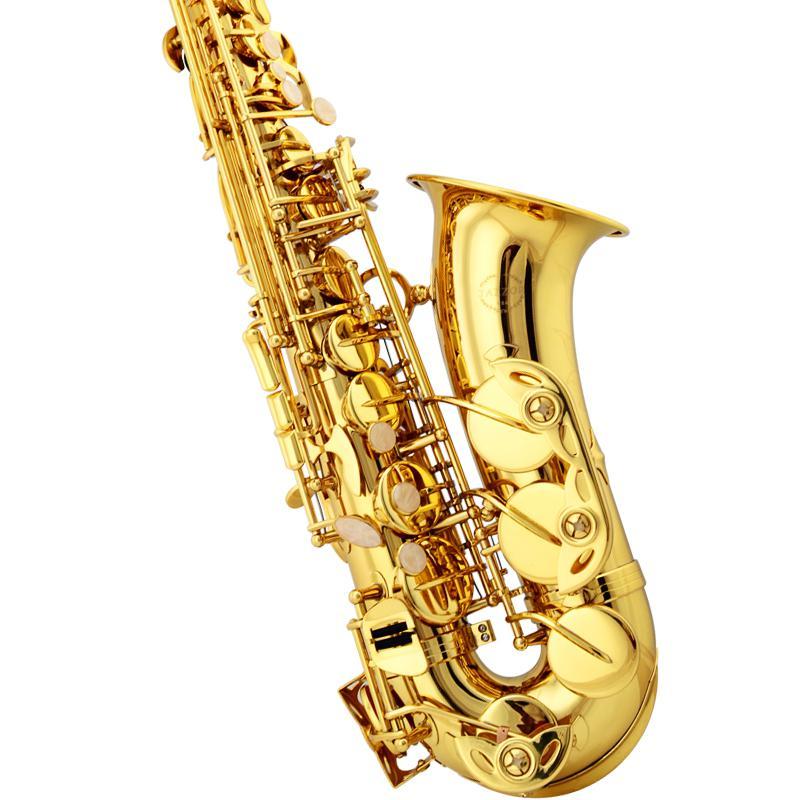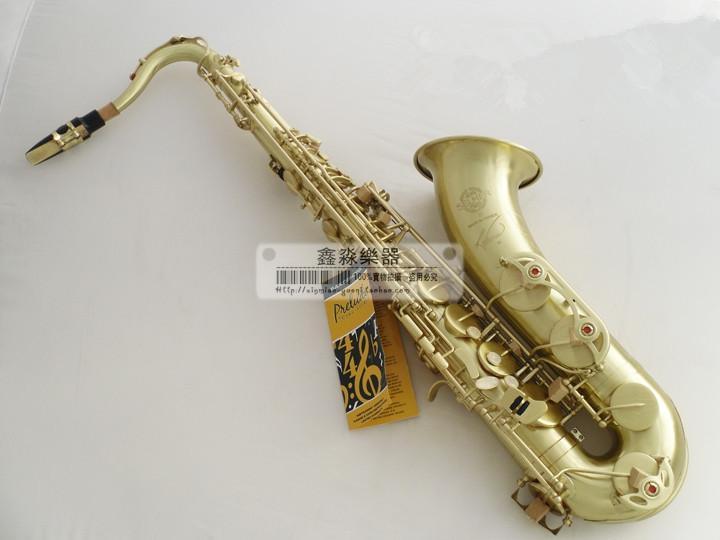The first image is the image on the left, the second image is the image on the right. Assess this claim about the two images: "One of the images shows a saxophone and a pamphlet while the other shows only a saxophone.". Correct or not? Answer yes or no. Yes. The first image is the image on the left, the second image is the image on the right. For the images shown, is this caption "A tag is connected to the sax in the image on the right." true? Answer yes or no. Yes. 